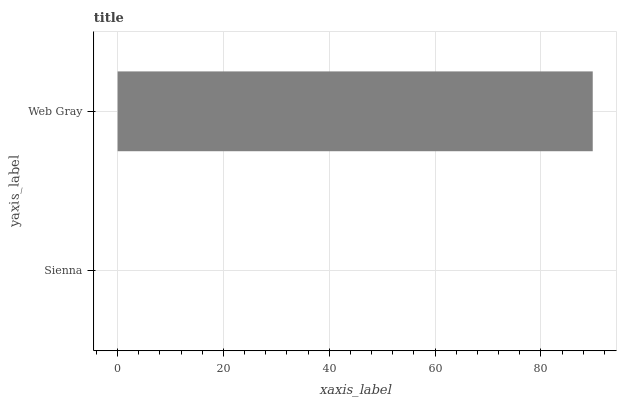Is Sienna the minimum?
Answer yes or no. Yes. Is Web Gray the maximum?
Answer yes or no. Yes. Is Web Gray the minimum?
Answer yes or no. No. Is Web Gray greater than Sienna?
Answer yes or no. Yes. Is Sienna less than Web Gray?
Answer yes or no. Yes. Is Sienna greater than Web Gray?
Answer yes or no. No. Is Web Gray less than Sienna?
Answer yes or no. No. Is Web Gray the high median?
Answer yes or no. Yes. Is Sienna the low median?
Answer yes or no. Yes. Is Sienna the high median?
Answer yes or no. No. Is Web Gray the low median?
Answer yes or no. No. 